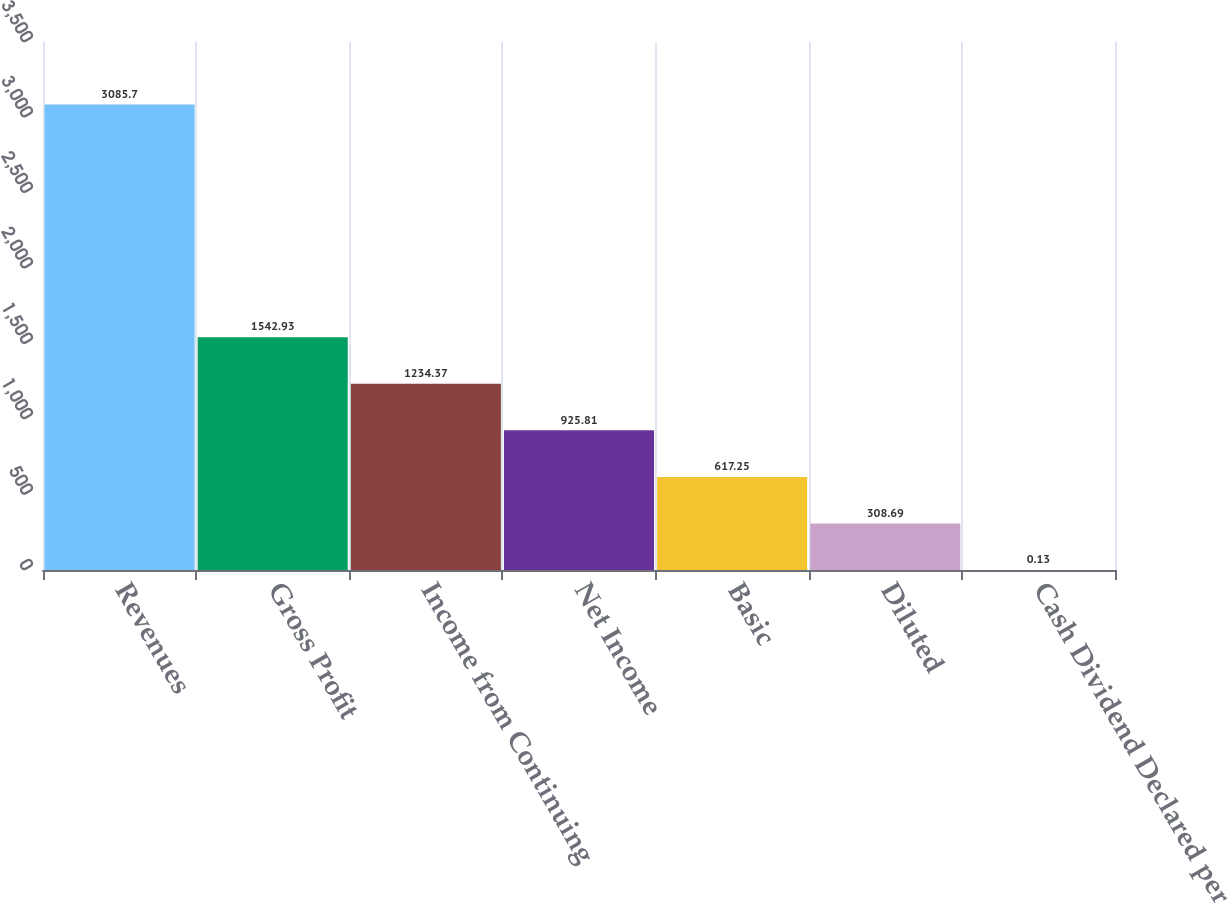Convert chart to OTSL. <chart><loc_0><loc_0><loc_500><loc_500><bar_chart><fcel>Revenues<fcel>Gross Profit<fcel>Income from Continuing<fcel>Net Income<fcel>Basic<fcel>Diluted<fcel>Cash Dividend Declared per<nl><fcel>3085.7<fcel>1542.93<fcel>1234.37<fcel>925.81<fcel>617.25<fcel>308.69<fcel>0.13<nl></chart> 